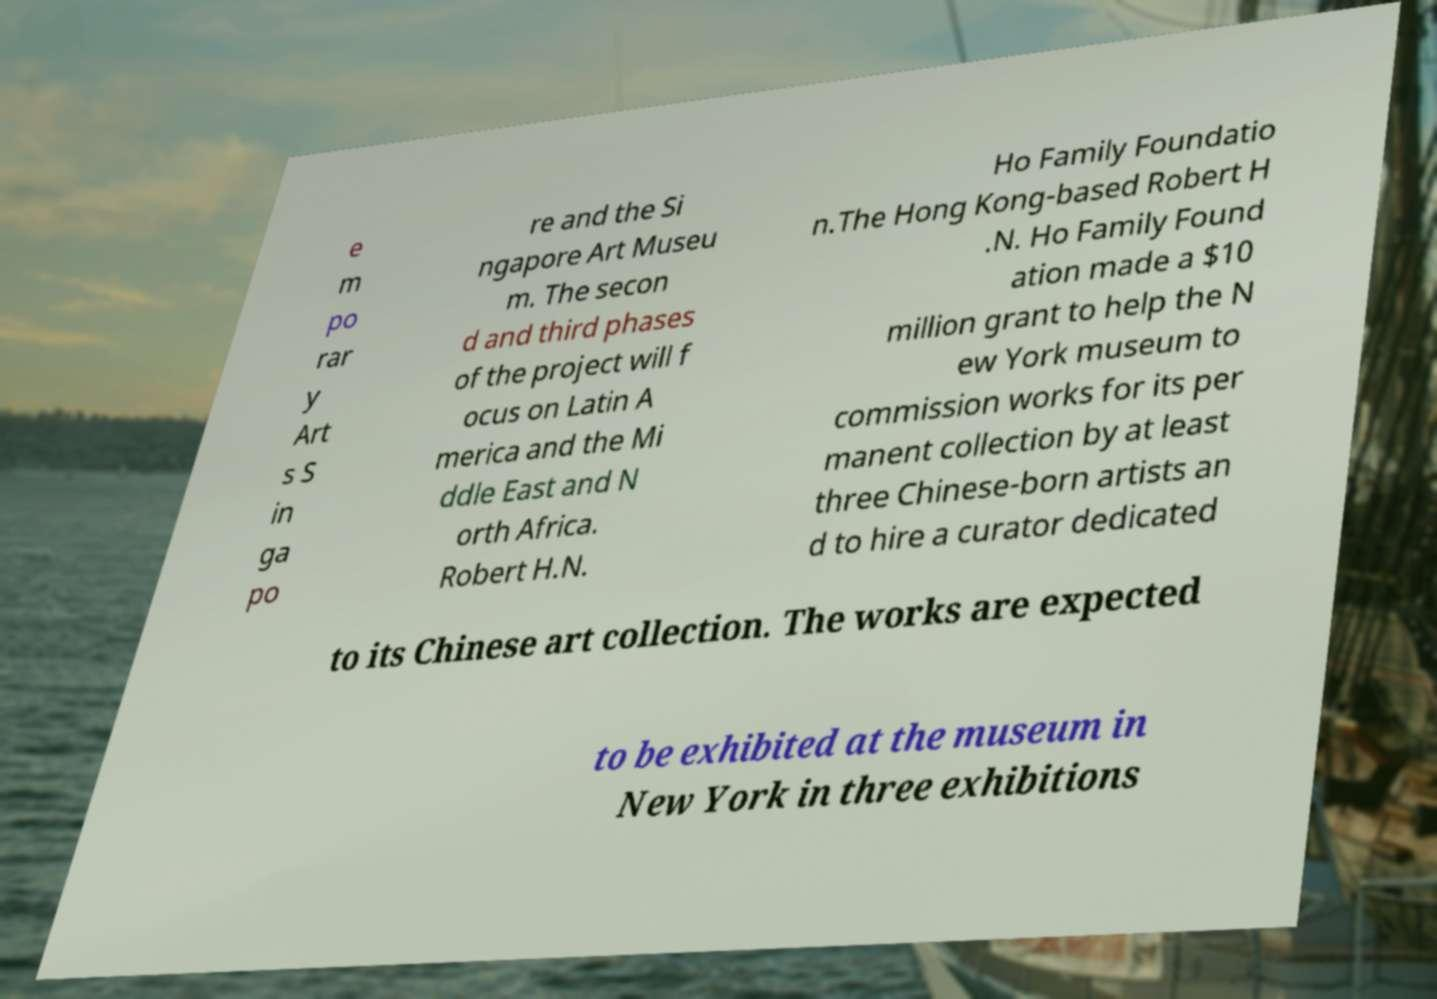There's text embedded in this image that I need extracted. Can you transcribe it verbatim? e m po rar y Art s S in ga po re and the Si ngapore Art Museu m. The secon d and third phases of the project will f ocus on Latin A merica and the Mi ddle East and N orth Africa. Robert H.N. Ho Family Foundatio n.The Hong Kong-based Robert H .N. Ho Family Found ation made a $10 million grant to help the N ew York museum to commission works for its per manent collection by at least three Chinese-born artists an d to hire a curator dedicated to its Chinese art collection. The works are expected to be exhibited at the museum in New York in three exhibitions 